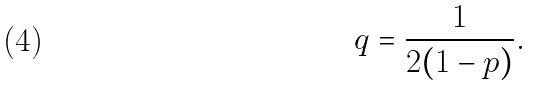Convert formula to latex. <formula><loc_0><loc_0><loc_500><loc_500>q = \frac { 1 } { 2 ( 1 - p ) } .</formula> 